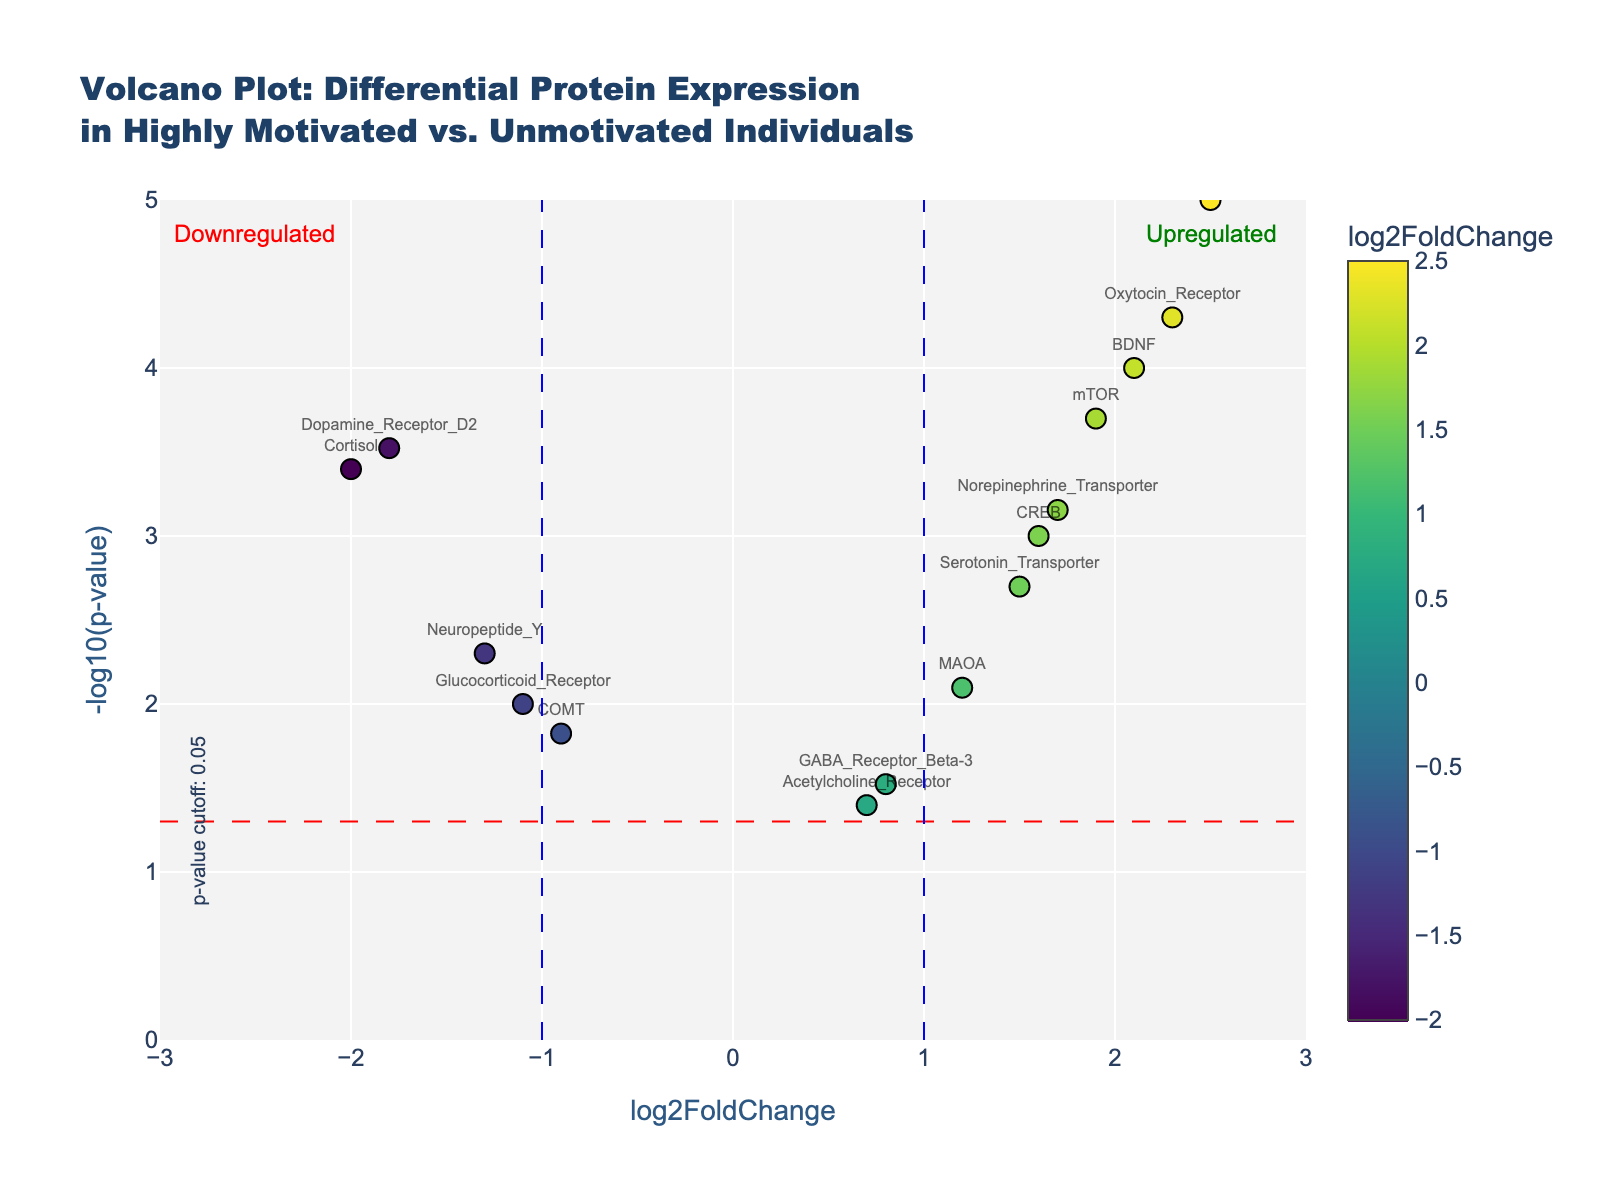What is the title of the plot? The title is located at the top of the figure, which reads "Volcano Plot: Differential Protein Expression in Highly Motivated vs. Unmotivated Individuals".
Answer: Volcano Plot: Differential Protein Expression in Highly Motivated vs. Unmotivated Individuals What do the x and y axes represent? The x-axis represents "log2FoldChange" and the y-axis represents "-log10(p-value)", as indicated by the axis titles.
Answer: x: log2FoldChange, y: -log10(p-value) How many proteins are shown in the plot? By counting the labels for each protein name in the plot, we can see that there are 15 proteins displayed.
Answer: 15 Which protein has the highest log2FoldChange? The highest log2FoldChange is represented by the data point farthest to the right on the x-axis which is labeled "Endorphin" (log2FoldChange = 2.5).
Answer: Endorphin Which protein has the lowest p-value? The lowest p-value corresponds to the highest point on the y-axis, which is labeled "Endorphin" (p-value = 0.00001).
Answer: Endorphin Name one protein that is significantly upregulated (log2FoldChange > 1 and p-value < 0.05)? Observing the plot for points with log2FoldChange > 1 and p-value < 0.05, one such example is "Oxytocin_Receptor".
Answer: Oxytocin_Receptor Name one protein that is significantly downregulated (log2FoldChange < -1 and p-value < 0.05)? Observing the plot for points with log2FoldChange < -1 and p-value < 0.05, one such example is "Cortisol".
Answer: Cortisol Which protein is closest to a neutral log2FoldChange but has a low p-value? By identifying the data point that is closest to 0 on the x-axis while having a relatively high y-value, "GABA_Receptor_Beta-3" fits this criteria.
Answer: GABA_Receptor_Beta-3 How many proteins exceed the -log10(p-value) threshold of 1.3? Counting the points above the p-value cutoff line (red dashed line at y = 1.3), there are 13 such proteins.
Answer: 13 What do the annotations at the top right and left corners of the plot indicate? The top right annotation indicates "Upregulated", while the top left annotation indicates "Downregulated". These indicate the direction of expression relative to motivation status (upregulated being more expressed in highly motivated individuals and downregulated being more expressed in unmotivated individuals).
Answer: Upregulated, Downregulated 